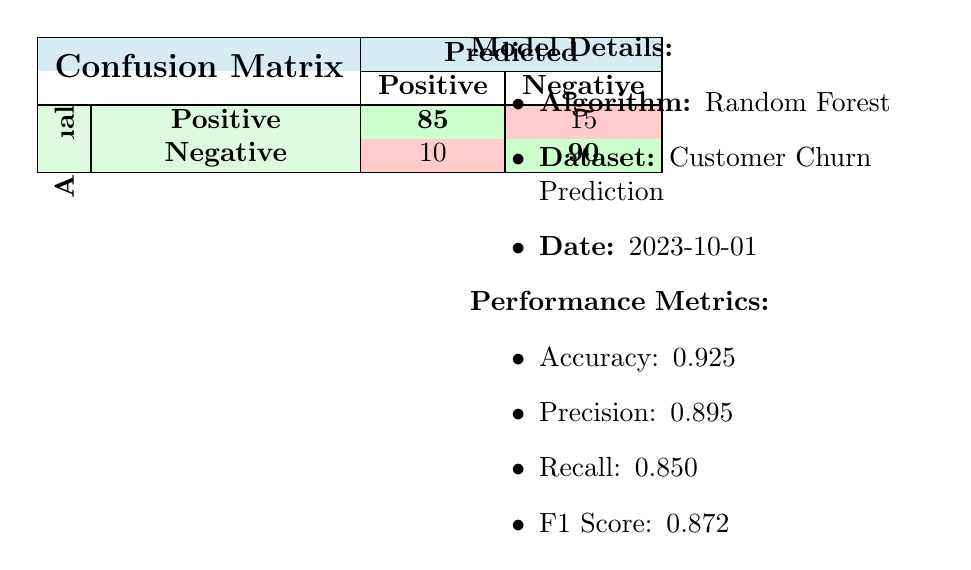What is the number of true positives? The true positives are the cases where the model correctly predicted positive outcomes. According to the confusion matrix, this value is represented by the cell under "Actual Positive" and "Predicted Positive," which is 85.
Answer: 85 What is the accuracy of the model? The accuracy is calculated as the total number of correct predictions (true positives + true negatives) divided by the total number of predictions. Here, it is 85 (True Positives) + 90 (True Negatives) = 175 correct predictions. The total predictions are 85 + 15 + 10 + 90 = 200. Therefore, accuracy = 175/200 = 0.925.
Answer: 0.925 What is the number of false negatives? The false negatives are the instances where the model incorrectly predicted negative outcomes while the actual outcomes were positive. This is represented by the cell under "Actual Positive" and "Predicted Negative," which shows the value 15.
Answer: 15 What is the precision of the model? Precision is calculated as the number of true positives divided by the sum of true positives and false positives. In this case, it is 85 (True Positives) / (85 (True Positives) + 10 (False Positives)) = 85/95 = 0.895.
Answer: 0.895 Did the model classify more actual positives as negative? To determine this, we compare the number of false negatives (15) with true positives (85). Since there are fewer actual positives classified as negative than those classified correctly as positive, the answer is no.
Answer: No What is the total number of negative predictions made? The total negative predictions consist of both true negatives and false positives. We need to sum these values: true negatives (90) + false positives (10), which equals 100.
Answer: 100 How many total predictions were made in the negative class? Total predictions in the negative class include false positives and true negatives. From the confusion matrix, false positives is 10 and true negatives is 90. Summing these gives 10 + 90 = 100.
Answer: 100 What percentage of predicted positives were true positives? To find the percentage of predicted positives that were true positives, we use the formula: (True Positives / Predicted Positives) * 100. Here, True Positives = 85 and Predicted Positives = 85 + 10 = 95. Therefore, (85/95) * 100 = 89.47%, approximately 89.5%.
Answer: 89.5% What is the F1 Score in relation to precision and recall? The F1 Score is the harmonic mean of precision and recall, which can give insights into the model's performance. With precision at 0.895 and recall at 0.850, the F1 Score = 2 * (Precision * Recall) / (Precision + Recall) = 2 * (0.895 * 0.850) / (0.895 + 0.850) = approximately 0.872. Thus, the F1 Score effectively balances both metrics.
Answer: 0.872 